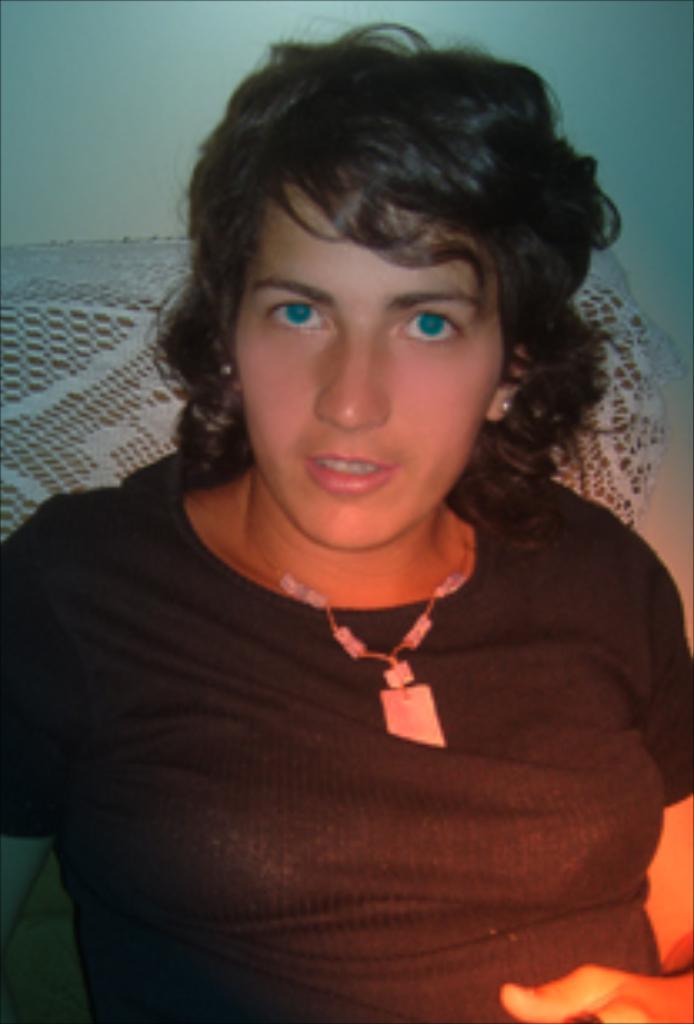Can you describe this image briefly? In the image there is a woman,she is wearing black shirt and behind the woman there is a wall. 